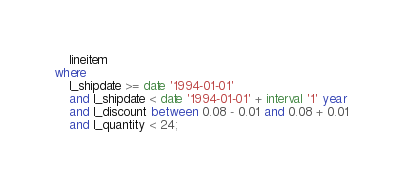Convert code to text. <code><loc_0><loc_0><loc_500><loc_500><_SQL_>    lineitem
where
    l_shipdate >= date '1994-01-01'
    and l_shipdate < date '1994-01-01' + interval '1' year
    and l_discount between 0.08 - 0.01 and 0.08 + 0.01
    and l_quantity < 24;

</code> 